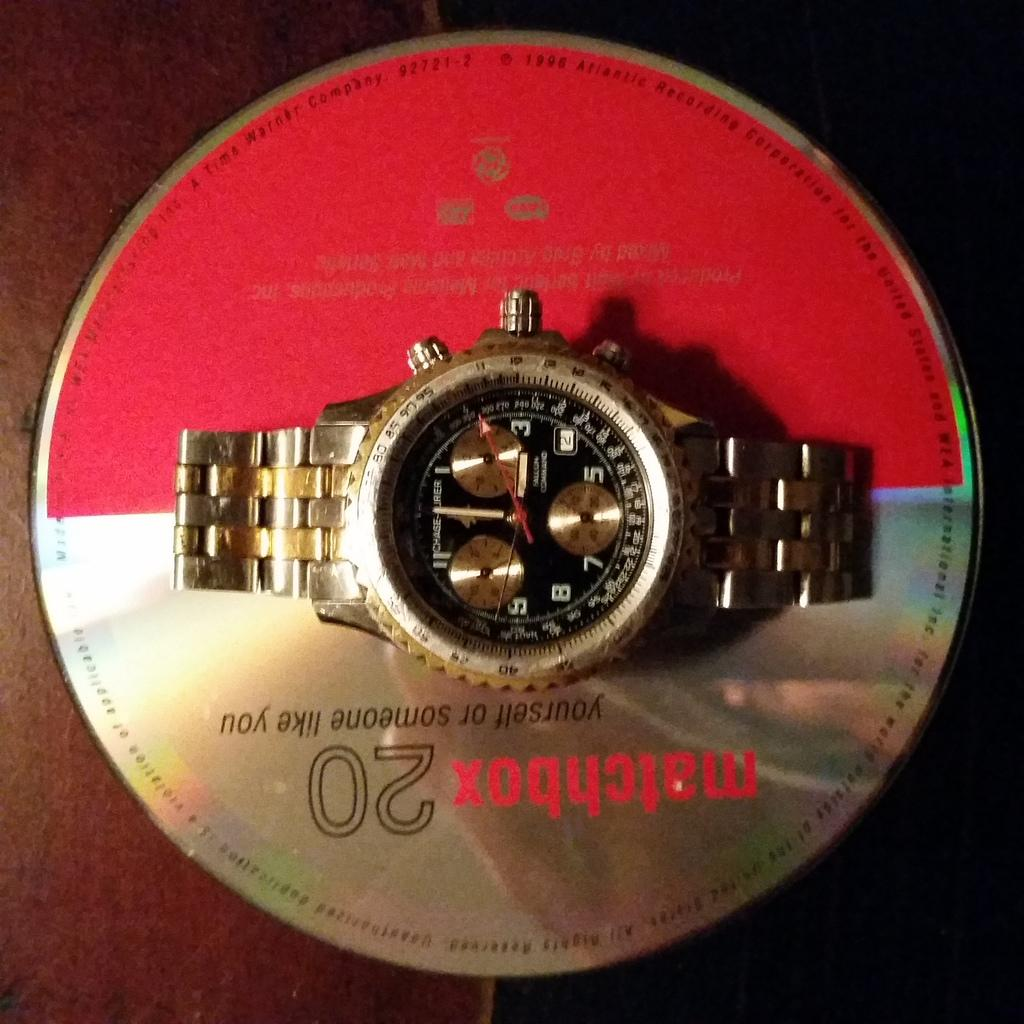<image>
Give a short and clear explanation of the subsequent image. Watch placed on top of a Matchbox 20 cd sitting on a table 